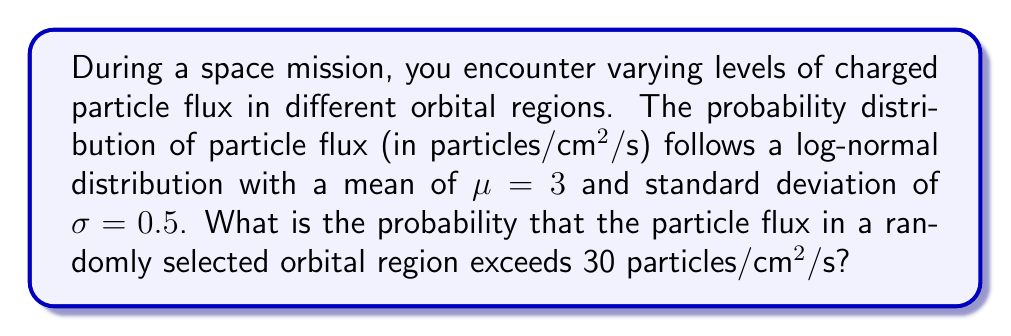Could you help me with this problem? Let's approach this step-by-step:

1) In a log-normal distribution, the natural logarithm of the random variable is normally distributed. Let X be the particle flux, then ln(X) follows a normal distribution.

2) We need to find P(X > 30), which is equivalent to P(ln(X) > ln(30)).

3) For a normal distribution, we use the z-score formula:
   $$z = \frac{ln(x) - \mu}{\sigma}$$

4) We're given $\mu = 3$ and $\sigma = 0.5$ for ln(X), not for X itself.

5) Calculate z for ln(30):
   $$z = \frac{ln(30) - 3}{0.5} = \frac{3.4012 - 3}{0.5} = 0.8024$$

6) We need to find P(Z > 0.8024), where Z is a standard normal variable.

7) Using a standard normal table or calculator, we can find:
   P(Z < 0.8024) ≈ 0.7888

8) Therefore, P(Z > 0.8024) = 1 - 0.7888 = 0.2112

So, the probability that the particle flux exceeds 30 particles/cm²/s is approximately 0.2112 or 21.12%.
Answer: 0.2112 